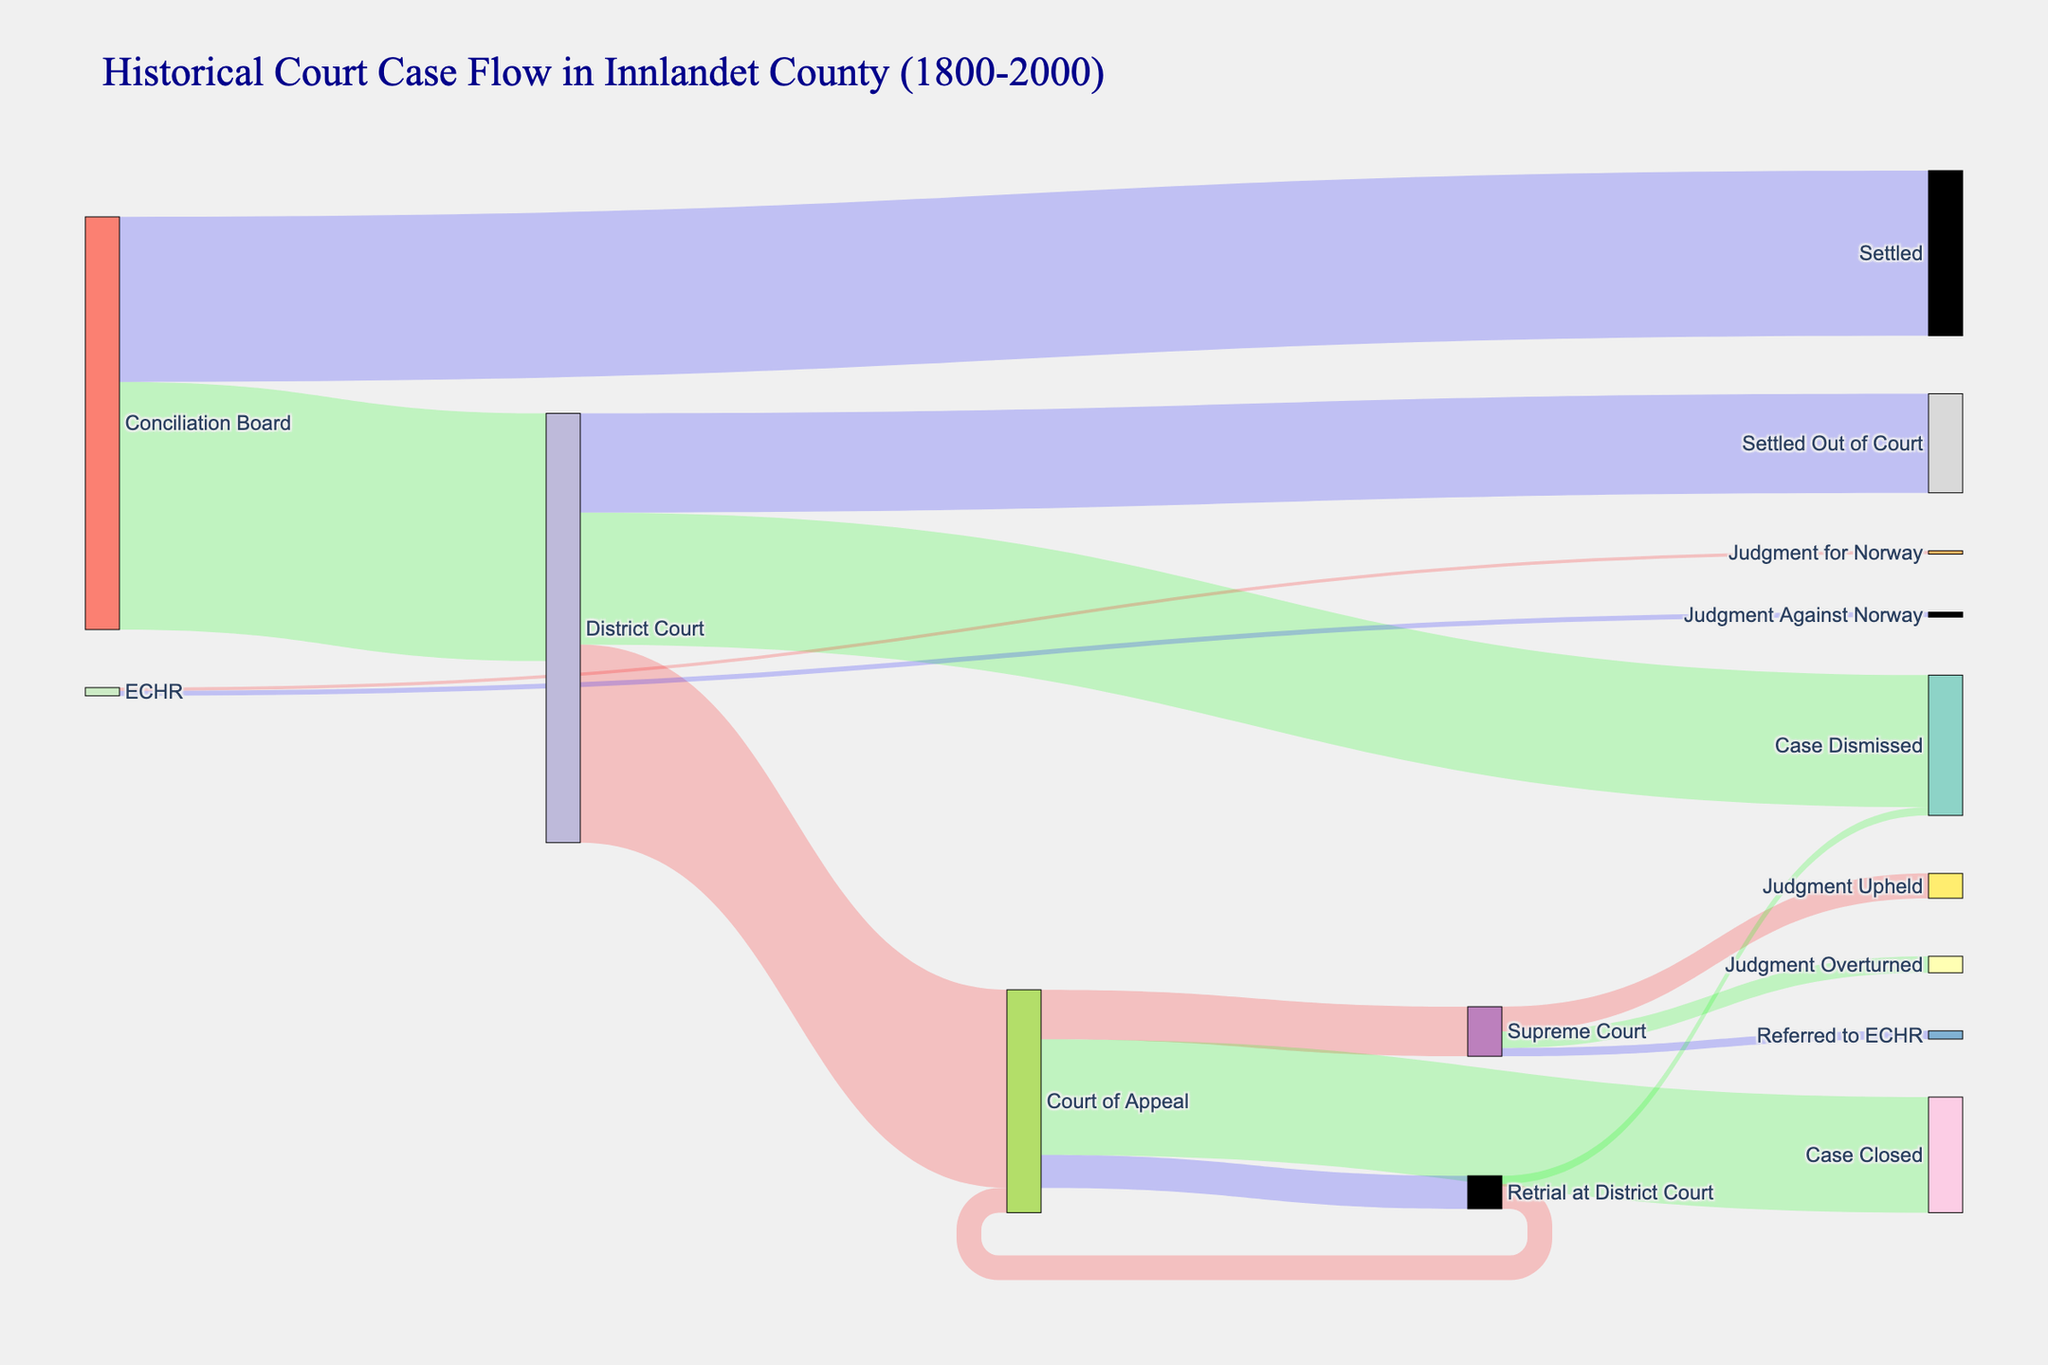What's the title of the figure? The title is usually displayed at the top of the figure, reflecting the content or subject of the visualization. Here, the title provides the context of the historical data being shown.
Answer: Historical Court Case Flow in Innlandet County (1800-2000) What's the total number of cases that started at the District Court? To find the total number of cases at the District Court, sum the values flowing out of the District Court. These values are 1200 (to Court of Appeal) + 800 (Case Dismissed) + 600 (Settled Out of Court). Total = 1200 + 800 + 600 = 2600.
Answer: 2600 How many cases were settled out of court directly from the District Court? Look for the link originating from the District Court and leading to "Settled Out of Court". The value associated with this link indicates the number of such cases.
Answer: 600 Which court did the majority of cases from the Conciliation Board go to? Compare the values of the links from the Conciliation Board. The flow with the highest value indicates the destination of the majority of cases. The Conciliation Board has 1500 cases going to the District Court and 1000 cases getting Settled.
Answer: District Court How many cases reached the Supreme Court after being handled by the Court of Appeal? The value of the link from the Court of Appeal to the Supreme Court shows how many cases moved from one to the other.
Answer: 300 How many cases in total were settled at any stage? To find the total number of settled cases, sum the values leading to any form of settlement. These are 600 (Settled Out of Court from District Court) and 1000 (Settled from the Conciliation Board). Total = 600 + 1000 = 1600.
Answer: 1600 After retrial at the District Court, how many cases were sent back to the Court of Appeal? Identify the link originating from "Retrial at District Court" and leading to "Court of Appeal". The value associated with this flow is the number of cases.
Answer: 150 What proportion of the Supreme Court cases were referred to the European Court of Human Rights (ECHR)? To find this proportion, divide the number of cases referred to ECHR (50) by the total number of cases reaching the Supreme Court (300 from Court of Appeal). Proportion = 50 / 300 = 1/6.
Answer: 1/6 Did more cases get dismissed at the District Court level or after a retrial at the District Court? Compare the values for cases dismissed directly from the District Court (800) and the cases dismissed after a retrial (50). 800 is greater than 50.
Answer: District Court How many cases were upheld by the Supreme Court? The value of the link leading from the Supreme Court to "Judgment Upheld" represents this number.
Answer: 150 